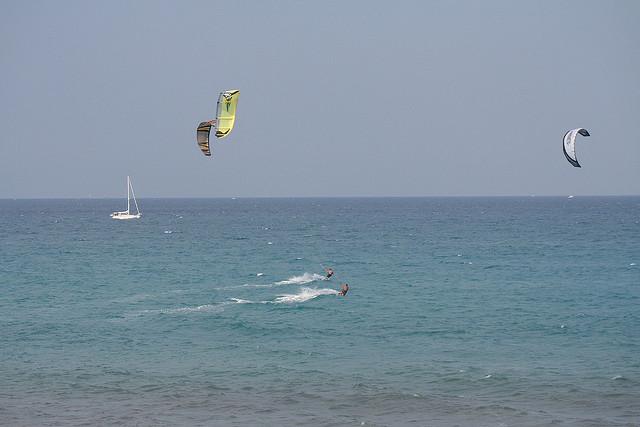Is there land in sight?
Give a very brief answer. No. What is the color of the water?
Quick response, please. Blue. How many boats do you see?
Concise answer only. 1. 